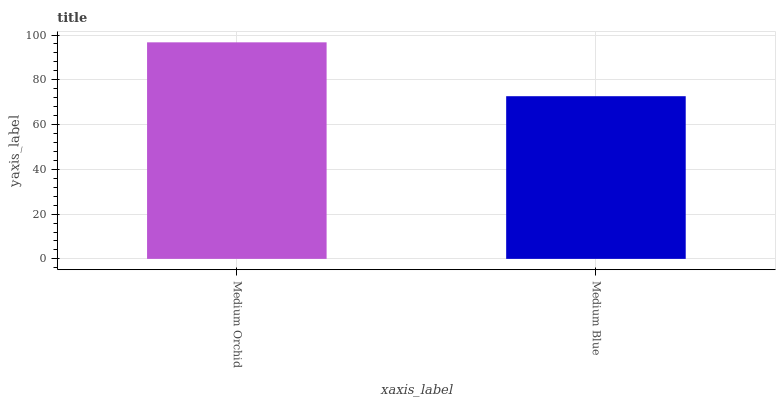Is Medium Blue the minimum?
Answer yes or no. Yes. Is Medium Orchid the maximum?
Answer yes or no. Yes. Is Medium Blue the maximum?
Answer yes or no. No. Is Medium Orchid greater than Medium Blue?
Answer yes or no. Yes. Is Medium Blue less than Medium Orchid?
Answer yes or no. Yes. Is Medium Blue greater than Medium Orchid?
Answer yes or no. No. Is Medium Orchid less than Medium Blue?
Answer yes or no. No. Is Medium Orchid the high median?
Answer yes or no. Yes. Is Medium Blue the low median?
Answer yes or no. Yes. Is Medium Blue the high median?
Answer yes or no. No. Is Medium Orchid the low median?
Answer yes or no. No. 